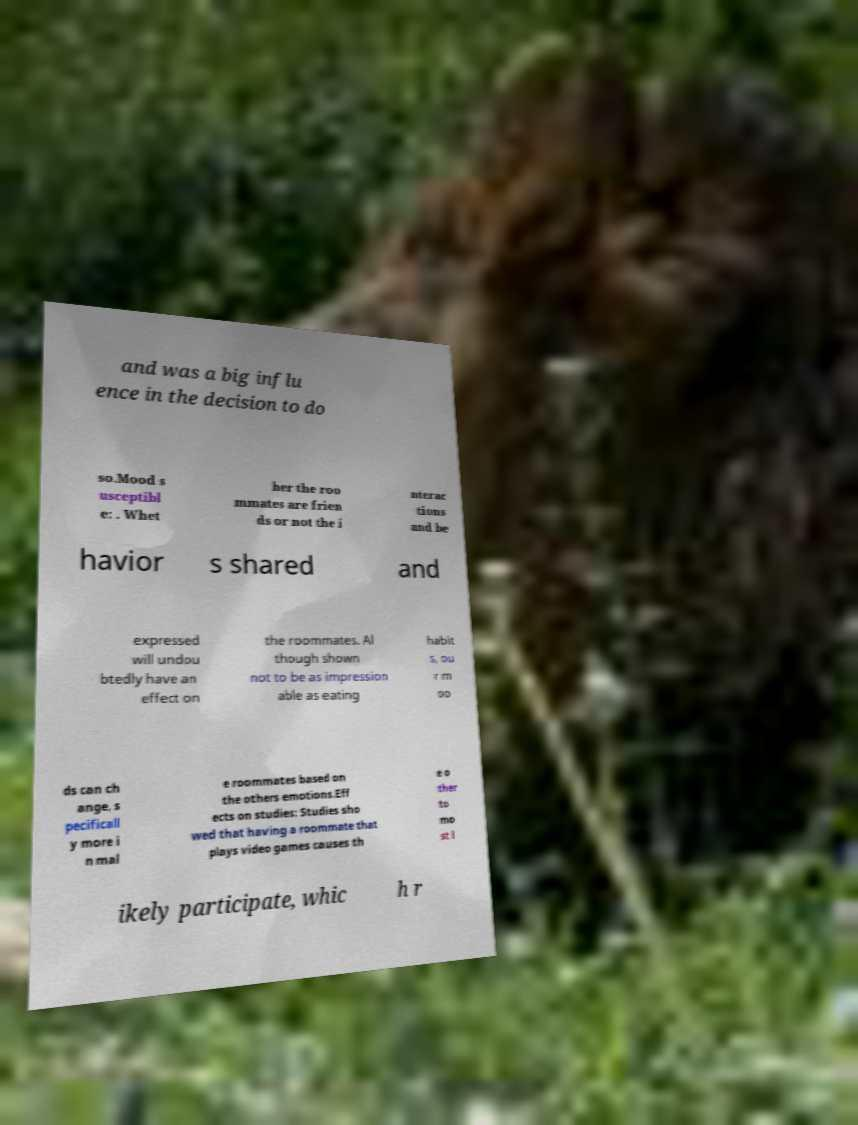Could you extract and type out the text from this image? and was a big influ ence in the decision to do so.Mood s usceptibl e: . Whet her the roo mmates are frien ds or not the i nterac tions and be havior s shared and expressed will undou btedly have an effect on the roommates. Al though shown not to be as impression able as eating habit s, ou r m oo ds can ch ange, s pecificall y more i n mal e roommates based on the others emotions.Eff ects on studies: Studies sho wed that having a roommate that plays video games causes th e o ther to mo st l ikely participate, whic h r 